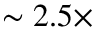<formula> <loc_0><loc_0><loc_500><loc_500>\sim 2 . 5 \times</formula> 